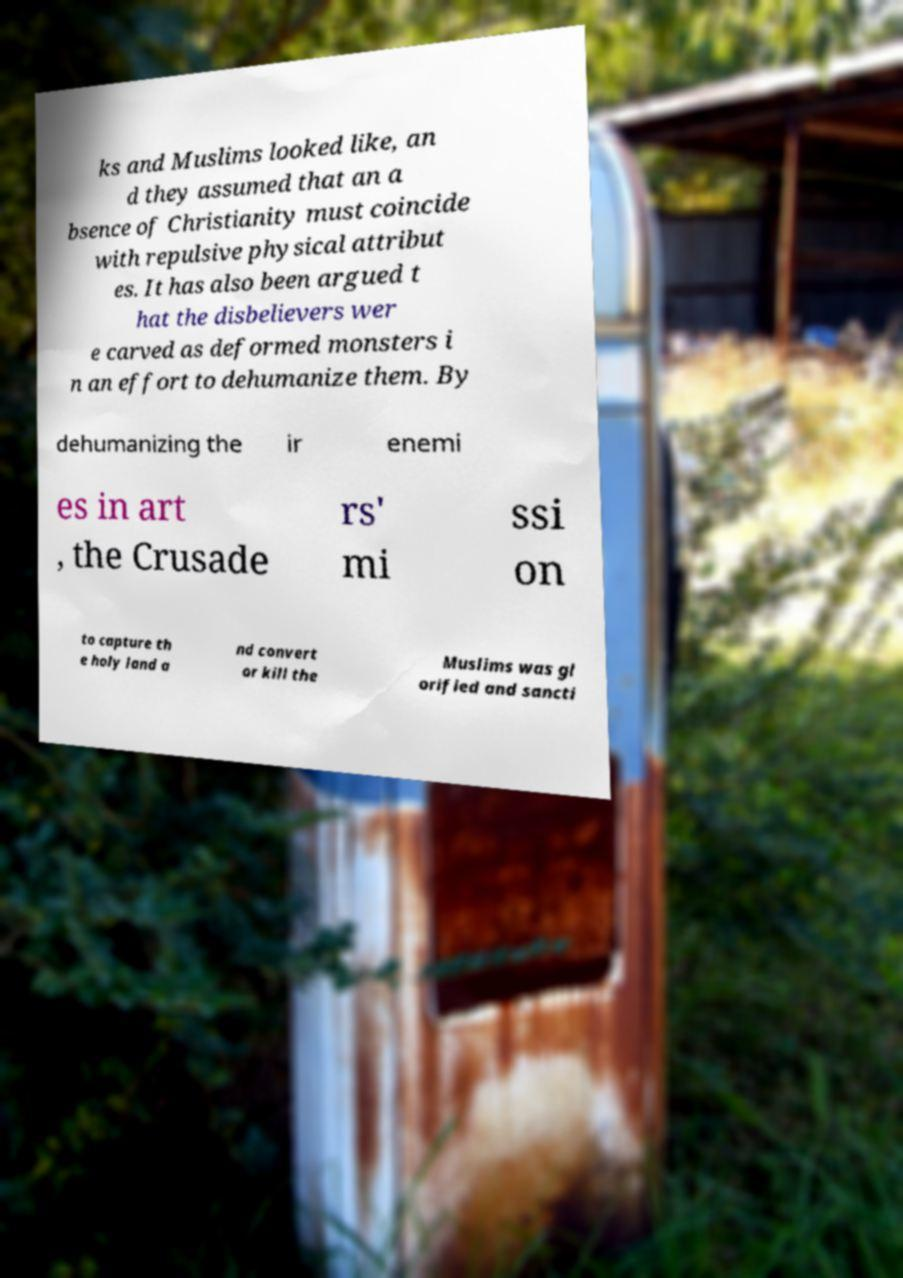There's text embedded in this image that I need extracted. Can you transcribe it verbatim? ks and Muslims looked like, an d they assumed that an a bsence of Christianity must coincide with repulsive physical attribut es. It has also been argued t hat the disbelievers wer e carved as deformed monsters i n an effort to dehumanize them. By dehumanizing the ir enemi es in art , the Crusade rs' mi ssi on to capture th e holy land a nd convert or kill the Muslims was gl orified and sancti 